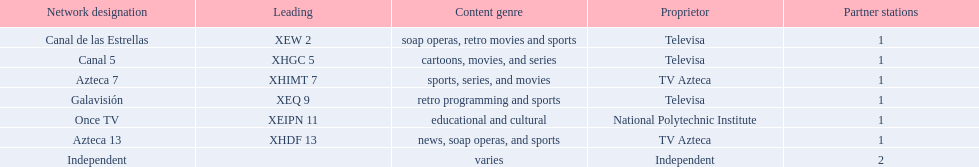What are each of the networks? Canal de las Estrellas, Canal 5, Azteca 7, Galavisión, Once TV, Azteca 13, Independent. Who owns them? Televisa, Televisa, TV Azteca, Televisa, National Polytechnic Institute, TV Azteca, Independent. Which networks aren't owned by televisa? Azteca 7, Once TV, Azteca 13, Independent. What type of programming do those networks offer? Sports, series, and movies, educational and cultural, news, soap operas, and sports, varies. And which network is the only one with sports? Azteca 7. 